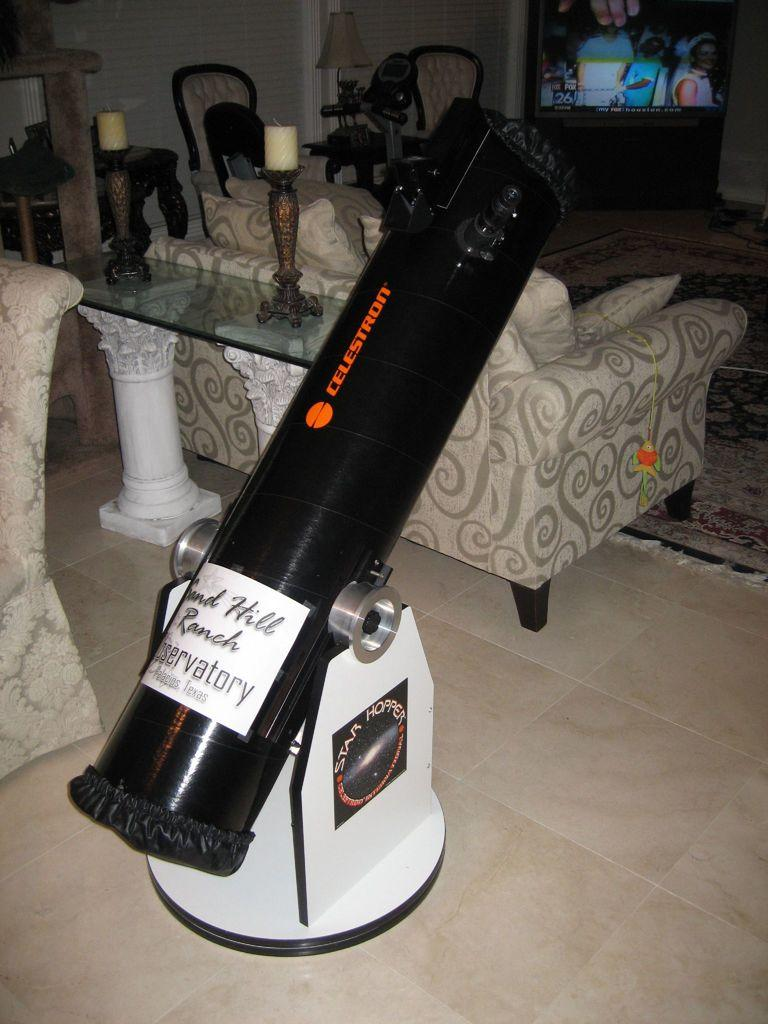What type of furniture is present in the image? There are sofas and chairs in the image. What objects can be seen providing light in the image? There are candles in the image. Can you describe the object in the image? Unfortunately, the facts provided do not give a specific description of the object. What part of the room is visible in the image? The floor is visible in the image. What type of container is present in the image? There is a glass in the image. What crime is being committed in the image? There is no indication of a crime being committed in the image. What need is being addressed by the presence of the glass in the image? The facts provided do not give any information about a need being addressed by the presence of the glass. 